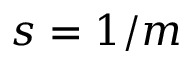<formula> <loc_0><loc_0><loc_500><loc_500>s = 1 / m</formula> 